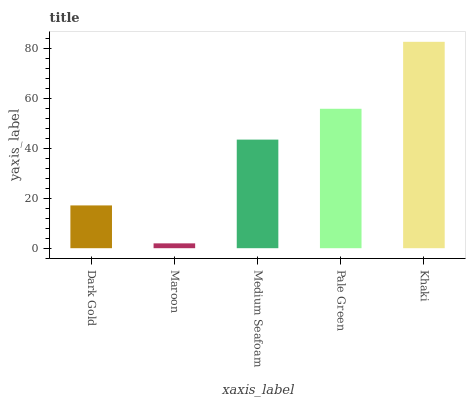Is Maroon the minimum?
Answer yes or no. Yes. Is Khaki the maximum?
Answer yes or no. Yes. Is Medium Seafoam the minimum?
Answer yes or no. No. Is Medium Seafoam the maximum?
Answer yes or no. No. Is Medium Seafoam greater than Maroon?
Answer yes or no. Yes. Is Maroon less than Medium Seafoam?
Answer yes or no. Yes. Is Maroon greater than Medium Seafoam?
Answer yes or no. No. Is Medium Seafoam less than Maroon?
Answer yes or no. No. Is Medium Seafoam the high median?
Answer yes or no. Yes. Is Medium Seafoam the low median?
Answer yes or no. Yes. Is Pale Green the high median?
Answer yes or no. No. Is Khaki the low median?
Answer yes or no. No. 